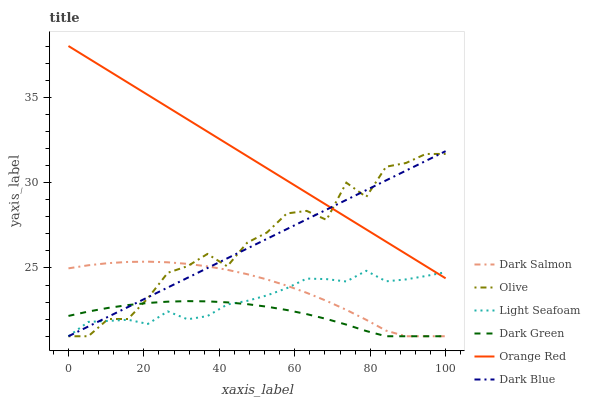Does Dark Green have the minimum area under the curve?
Answer yes or no. Yes. Does Orange Red have the maximum area under the curve?
Answer yes or no. Yes. Does Dark Blue have the minimum area under the curve?
Answer yes or no. No. Does Dark Blue have the maximum area under the curve?
Answer yes or no. No. Is Dark Blue the smoothest?
Answer yes or no. Yes. Is Olive the roughest?
Answer yes or no. Yes. Is Olive the smoothest?
Answer yes or no. No. Is Dark Blue the roughest?
Answer yes or no. No. Does Orange Red have the lowest value?
Answer yes or no. No. Does Orange Red have the highest value?
Answer yes or no. Yes. Does Dark Blue have the highest value?
Answer yes or no. No. Is Dark Salmon less than Orange Red?
Answer yes or no. Yes. Is Orange Red greater than Dark Salmon?
Answer yes or no. Yes. Does Dark Salmon intersect Orange Red?
Answer yes or no. No. 